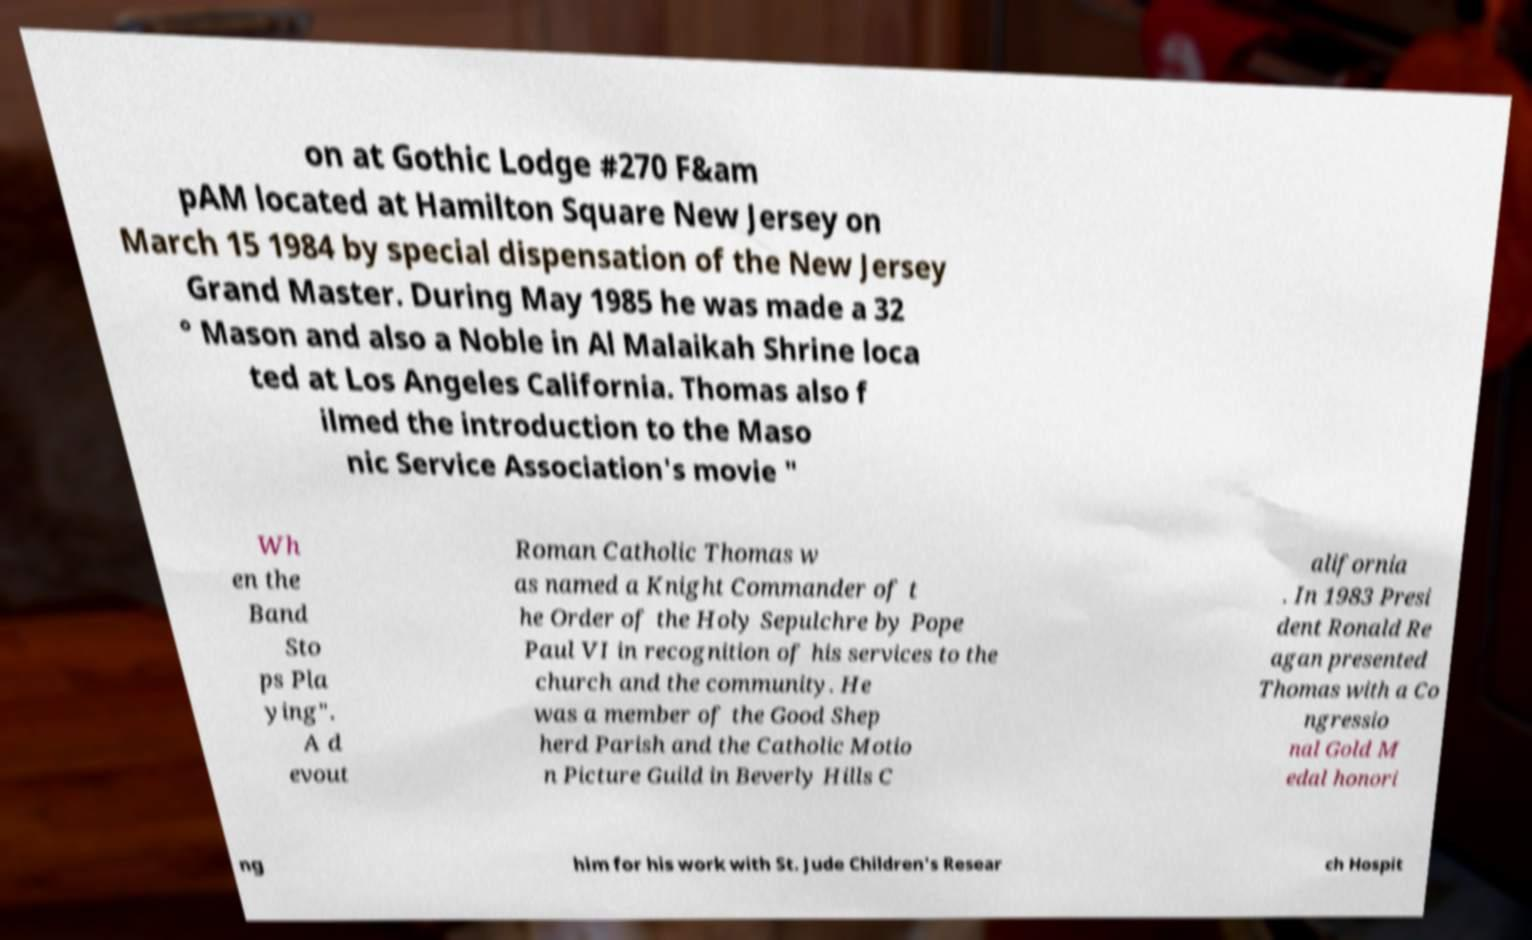What messages or text are displayed in this image? I need them in a readable, typed format. on at Gothic Lodge #270 F&am pAM located at Hamilton Square New Jersey on March 15 1984 by special dispensation of the New Jersey Grand Master. During May 1985 he was made a 32 ° Mason and also a Noble in Al Malaikah Shrine loca ted at Los Angeles California. Thomas also f ilmed the introduction to the Maso nic Service Association's movie " Wh en the Band Sto ps Pla ying". A d evout Roman Catholic Thomas w as named a Knight Commander of t he Order of the Holy Sepulchre by Pope Paul VI in recognition of his services to the church and the community. He was a member of the Good Shep herd Parish and the Catholic Motio n Picture Guild in Beverly Hills C alifornia . In 1983 Presi dent Ronald Re agan presented Thomas with a Co ngressio nal Gold M edal honori ng him for his work with St. Jude Children's Resear ch Hospit 